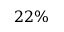<formula> <loc_0><loc_0><loc_500><loc_500>2 2 \%</formula> 